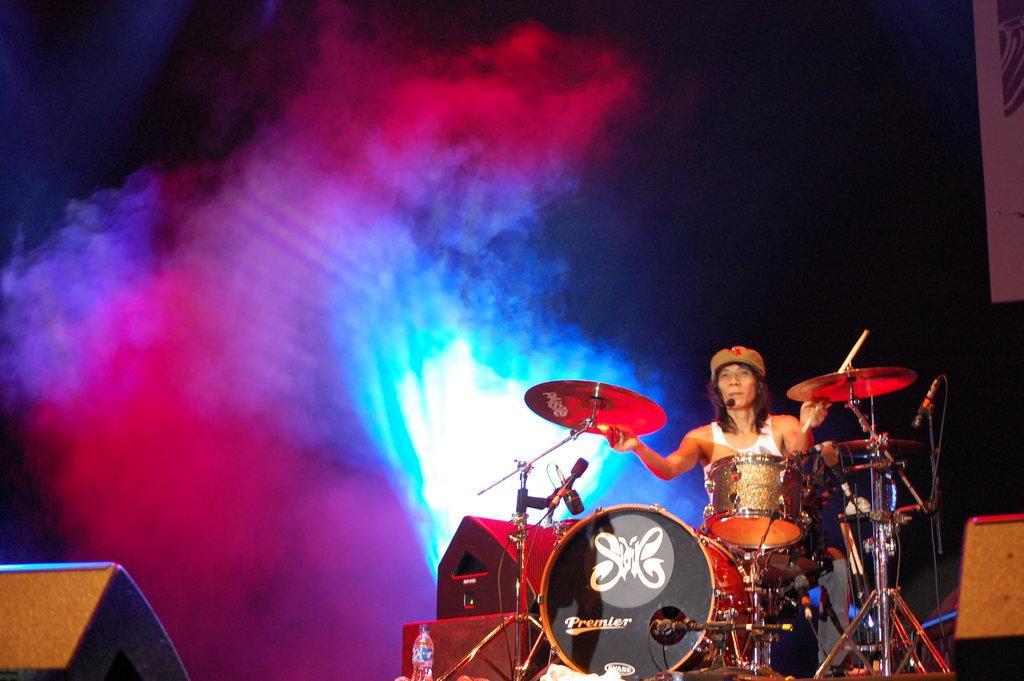Describe this image in one or two sentences. Here in this picture we can see a person sitting on a stool and he is playing drums which are present in front of him and we can see speakers also present beside him and we can see colorful lights and smoke over there. 